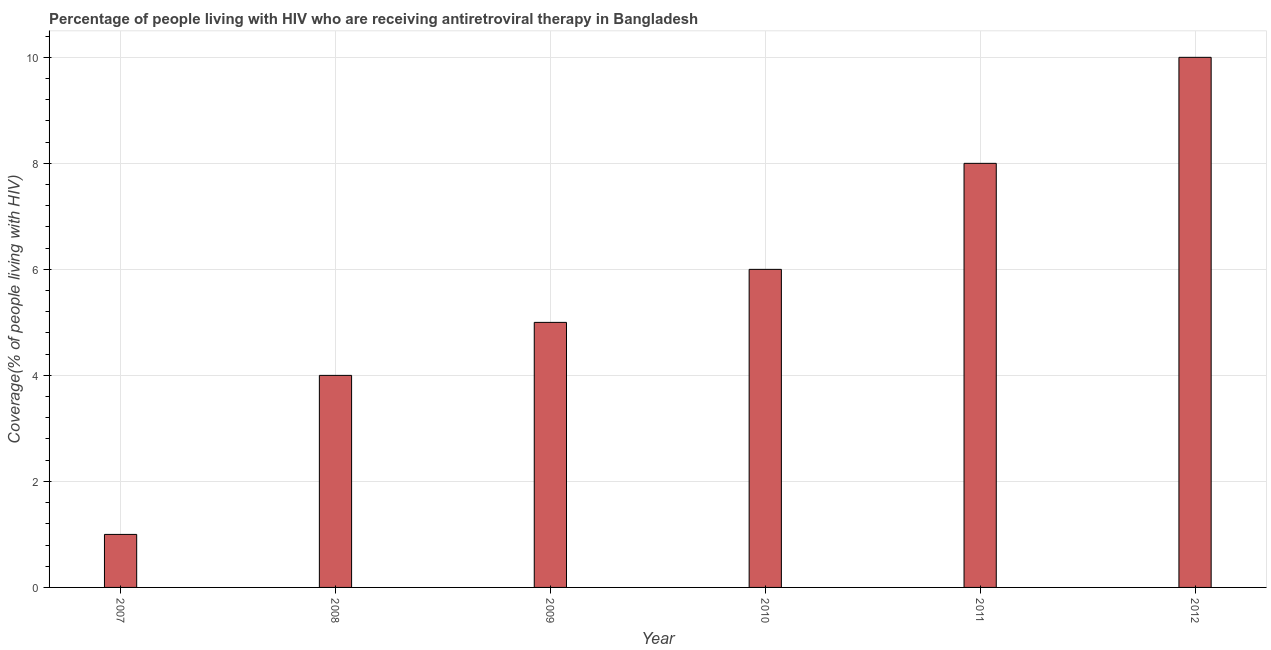What is the title of the graph?
Give a very brief answer. Percentage of people living with HIV who are receiving antiretroviral therapy in Bangladesh. What is the label or title of the Y-axis?
Keep it short and to the point. Coverage(% of people living with HIV). What is the antiretroviral therapy coverage in 2010?
Keep it short and to the point. 6. Across all years, what is the maximum antiretroviral therapy coverage?
Your answer should be compact. 10. Across all years, what is the minimum antiretroviral therapy coverage?
Give a very brief answer. 1. In which year was the antiretroviral therapy coverage minimum?
Give a very brief answer. 2007. What is the difference between the antiretroviral therapy coverage in 2007 and 2009?
Make the answer very short. -4. What is the average antiretroviral therapy coverage per year?
Ensure brevity in your answer.  5. What is the median antiretroviral therapy coverage?
Provide a succinct answer. 5.5. What is the ratio of the antiretroviral therapy coverage in 2010 to that in 2011?
Keep it short and to the point. 0.75. Is the antiretroviral therapy coverage in 2009 less than that in 2010?
Ensure brevity in your answer.  Yes. Is the difference between the antiretroviral therapy coverage in 2009 and 2012 greater than the difference between any two years?
Your response must be concise. No. Is the sum of the antiretroviral therapy coverage in 2007 and 2010 greater than the maximum antiretroviral therapy coverage across all years?
Ensure brevity in your answer.  No. What is the difference between the highest and the lowest antiretroviral therapy coverage?
Offer a very short reply. 9. In how many years, is the antiretroviral therapy coverage greater than the average antiretroviral therapy coverage taken over all years?
Offer a terse response. 3. How many years are there in the graph?
Give a very brief answer. 6. What is the difference between two consecutive major ticks on the Y-axis?
Keep it short and to the point. 2. What is the Coverage(% of people living with HIV) of 2007?
Keep it short and to the point. 1. What is the Coverage(% of people living with HIV) of 2008?
Keep it short and to the point. 4. What is the Coverage(% of people living with HIV) of 2009?
Give a very brief answer. 5. What is the Coverage(% of people living with HIV) of 2010?
Offer a very short reply. 6. What is the Coverage(% of people living with HIV) of 2012?
Make the answer very short. 10. What is the difference between the Coverage(% of people living with HIV) in 2007 and 2008?
Your answer should be very brief. -3. What is the difference between the Coverage(% of people living with HIV) in 2007 and 2011?
Offer a terse response. -7. What is the difference between the Coverage(% of people living with HIV) in 2008 and 2012?
Your answer should be compact. -6. What is the difference between the Coverage(% of people living with HIV) in 2009 and 2010?
Offer a very short reply. -1. What is the difference between the Coverage(% of people living with HIV) in 2009 and 2011?
Your response must be concise. -3. What is the difference between the Coverage(% of people living with HIV) in 2010 and 2011?
Your answer should be compact. -2. What is the difference between the Coverage(% of people living with HIV) in 2011 and 2012?
Offer a terse response. -2. What is the ratio of the Coverage(% of people living with HIV) in 2007 to that in 2008?
Ensure brevity in your answer.  0.25. What is the ratio of the Coverage(% of people living with HIV) in 2007 to that in 2009?
Your response must be concise. 0.2. What is the ratio of the Coverage(% of people living with HIV) in 2007 to that in 2010?
Provide a short and direct response. 0.17. What is the ratio of the Coverage(% of people living with HIV) in 2008 to that in 2009?
Keep it short and to the point. 0.8. What is the ratio of the Coverage(% of people living with HIV) in 2008 to that in 2010?
Provide a short and direct response. 0.67. What is the ratio of the Coverage(% of people living with HIV) in 2008 to that in 2011?
Make the answer very short. 0.5. What is the ratio of the Coverage(% of people living with HIV) in 2008 to that in 2012?
Give a very brief answer. 0.4. What is the ratio of the Coverage(% of people living with HIV) in 2009 to that in 2010?
Keep it short and to the point. 0.83. What is the ratio of the Coverage(% of people living with HIV) in 2009 to that in 2011?
Give a very brief answer. 0.62. What is the ratio of the Coverage(% of people living with HIV) in 2009 to that in 2012?
Give a very brief answer. 0.5. What is the ratio of the Coverage(% of people living with HIV) in 2010 to that in 2012?
Give a very brief answer. 0.6. 